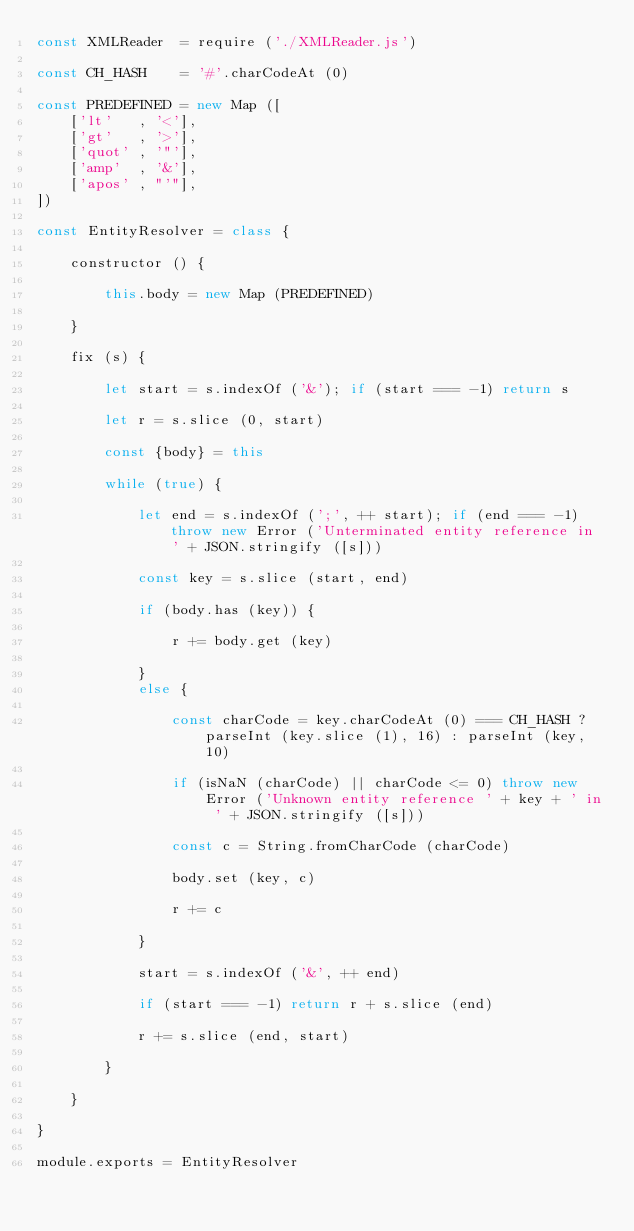Convert code to text. <code><loc_0><loc_0><loc_500><loc_500><_JavaScript_>const XMLReader  = require ('./XMLReader.js')

const CH_HASH    = '#'.charCodeAt (0)

const PREDEFINED = new Map ([
	['lt'   , '<'],
	['gt'   , '>'],
	['quot' , '"'],
	['amp'  , '&'],
	['apos' , "'"],
])

const EntityResolver = class {

	constructor () {

		this.body = new Map (PREDEFINED)

	}
	
	fix (s) {

		let start = s.indexOf ('&'); if (start === -1) return s
		
		let r = s.slice (0, start)
		
		const {body} = this
		
		while (true) {

			let end = s.indexOf (';', ++ start); if (end === -1) throw new Error ('Unterminated entity reference in ' + JSON.stringify ([s]))

			const key = s.slice (start, end)

			if (body.has (key)) {

				r += body.get (key)

			}
			else {

				const charCode = key.charCodeAt (0) === CH_HASH ? parseInt (key.slice (1), 16) : parseInt (key, 10)
				
				if (isNaN (charCode) || charCode <= 0) throw new Error ('Unknown entity reference ' + key + ' in ' + JSON.stringify ([s]))
				
				const c = String.fromCharCode (charCode)
				
				body.set (key, c)
				
				r += c

			}
			
			start = s.indexOf ('&', ++ end)
			
			if (start === -1) return r + s.slice (end)
			
			r += s.slice (end, start)
			
		}

	}

}

module.exports = EntityResolver</code> 